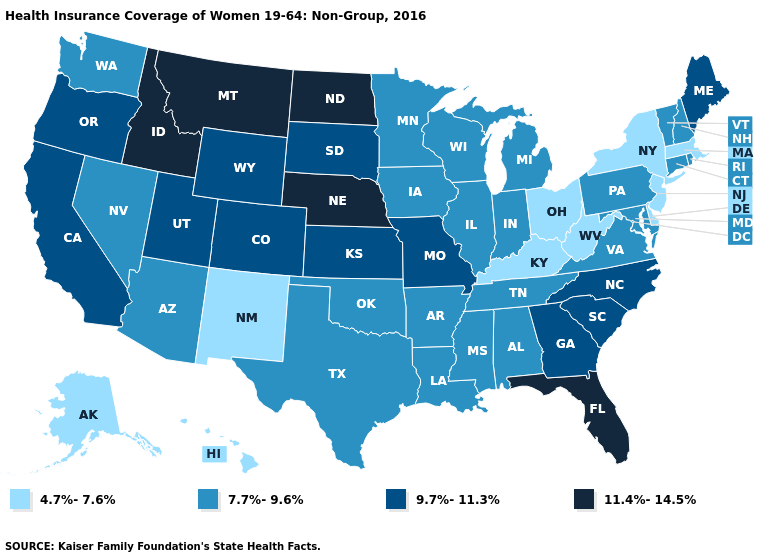Does Delaware have the same value as Utah?
Quick response, please. No. Name the states that have a value in the range 4.7%-7.6%?
Quick response, please. Alaska, Delaware, Hawaii, Kentucky, Massachusetts, New Jersey, New Mexico, New York, Ohio, West Virginia. Name the states that have a value in the range 7.7%-9.6%?
Concise answer only. Alabama, Arizona, Arkansas, Connecticut, Illinois, Indiana, Iowa, Louisiana, Maryland, Michigan, Minnesota, Mississippi, Nevada, New Hampshire, Oklahoma, Pennsylvania, Rhode Island, Tennessee, Texas, Vermont, Virginia, Washington, Wisconsin. Name the states that have a value in the range 11.4%-14.5%?
Answer briefly. Florida, Idaho, Montana, Nebraska, North Dakota. What is the highest value in the USA?
Answer briefly. 11.4%-14.5%. What is the value of Maine?
Write a very short answer. 9.7%-11.3%. Which states have the lowest value in the South?
Answer briefly. Delaware, Kentucky, West Virginia. What is the value of West Virginia?
Concise answer only. 4.7%-7.6%. Does the map have missing data?
Answer briefly. No. Does Wyoming have the lowest value in the USA?
Short answer required. No. Does Utah have the lowest value in the USA?
Give a very brief answer. No. Which states have the lowest value in the MidWest?
Be succinct. Ohio. What is the highest value in states that border Arizona?
Concise answer only. 9.7%-11.3%. Does Florida have the highest value in the South?
Give a very brief answer. Yes. Name the states that have a value in the range 4.7%-7.6%?
Give a very brief answer. Alaska, Delaware, Hawaii, Kentucky, Massachusetts, New Jersey, New Mexico, New York, Ohio, West Virginia. 